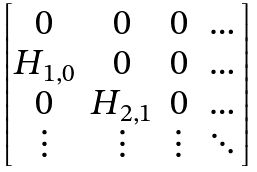Convert formula to latex. <formula><loc_0><loc_0><loc_500><loc_500>\begin{bmatrix} 0 & 0 & 0 & \dots \\ H _ { 1 , 0 } & 0 & 0 & \dots \\ 0 & H _ { 2 , 1 } & 0 & \dots \\ \vdots & \vdots & \vdots & \ddots \end{bmatrix}</formula> 